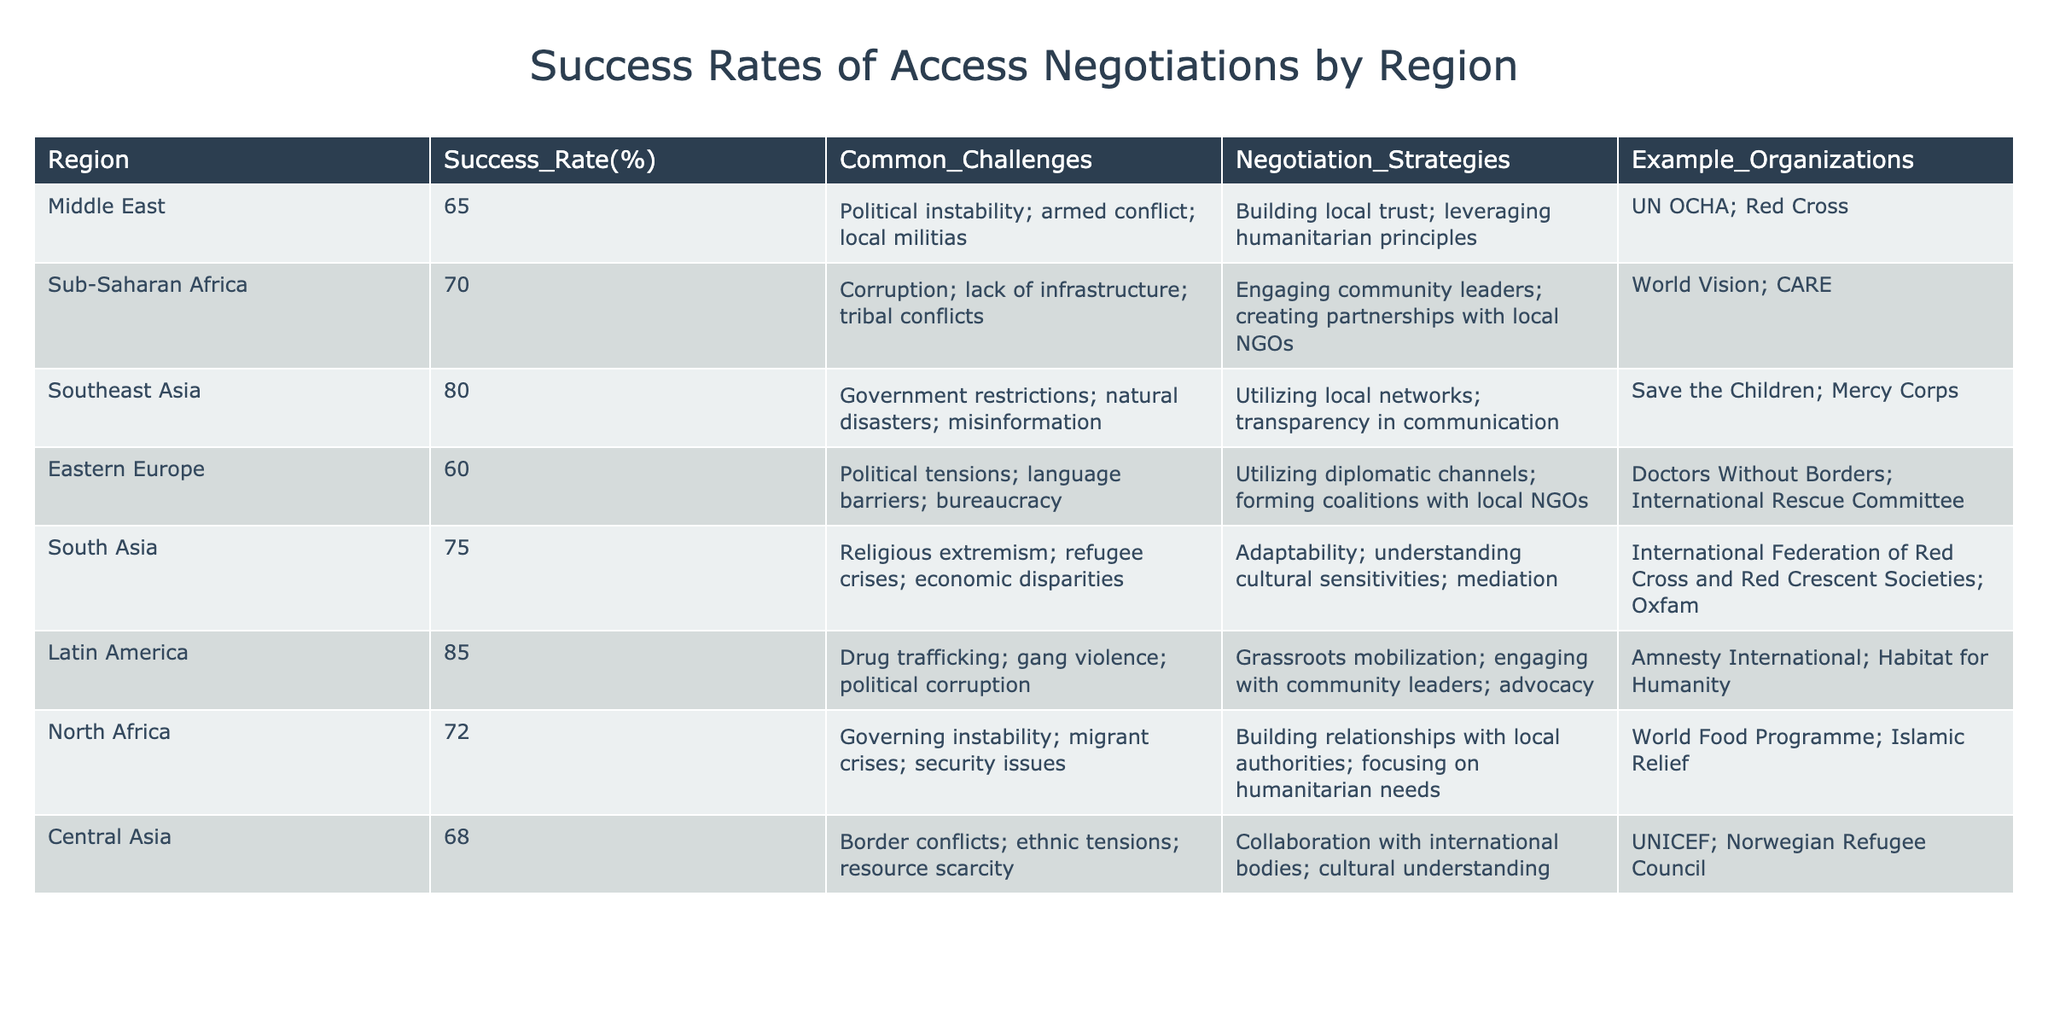What is the success rate of access negotiations in Southeast Asia? The table shows a specific column for success rates by region. Looking at the Southeast Asia row, the success rate is indicated as 80%.
Answer: 80% Which region has the highest success rate for access negotiations? When examining the table, we can see the success rates listed. Latin America has the highest percentage at 85%.
Answer: 85% Is the success rate in North Africa higher than that in Eastern Europe? By comparing the two regions, North Africa has a success rate of 72%, while Eastern Europe has 60%, confirming that North Africa's success rate is indeed higher.
Answer: Yes What is the average success rate of access negotiations from the regions listed? To find the average success rate, we sum the success rates of all regions: (65 + 70 + 80 + 60 + 75 + 85 + 72 + 68) = 605. There are 8 regions, so the average is 605/8 = 75.625.
Answer: 75.625 Which negotiation strategy is commonly used in Latin America? The table specifies common negotiation strategies associated with each region. For Latin America, the strategy is listed as grassroots mobilization; engaging with community leaders; advocacy.
Answer: Grassroots mobilization; engaging with community leaders; advocacy Are there more common challenges listed for Sub-Saharan Africa compared to Southeast Asia? Looking at the common challenges listed for both regions, Sub-Saharan Africa has three challenges (corruption, lack of infrastructure, tribal conflicts), whereas Southeast Asia has three as well (government restrictions, natural disasters, misinformation). Thus, they have an equal number of challenges.
Answer: No What is the difference in success rates between Latin America and North Africa? The success rate for Latin America is 85%, and for North Africa, it is 72%. The difference is calculated as: 85 - 72 = 13.
Answer: 13 Which organization is associated with the negotiation strategies in Central Asia? The table provides a column for example organizations linked to each region. For Central Asia, UNICEF and the Norwegian Refugee Council are mentioned as associated organizations.
Answer: UNICEF; Norwegian Refugee Council Is political instability a common challenge in the Middle East? The table lists common challenges for the Middle East, which includes political instability as one of the mentioned challenges.
Answer: Yes 